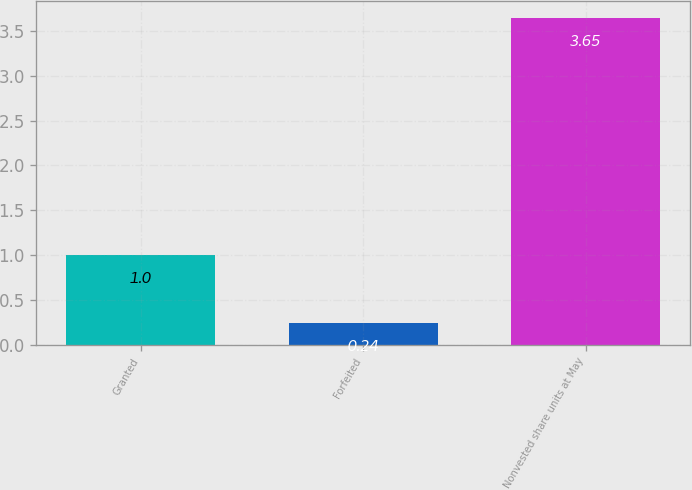Convert chart. <chart><loc_0><loc_0><loc_500><loc_500><bar_chart><fcel>Granted<fcel>Forfeited<fcel>Nonvested share units at May<nl><fcel>1<fcel>0.24<fcel>3.65<nl></chart> 